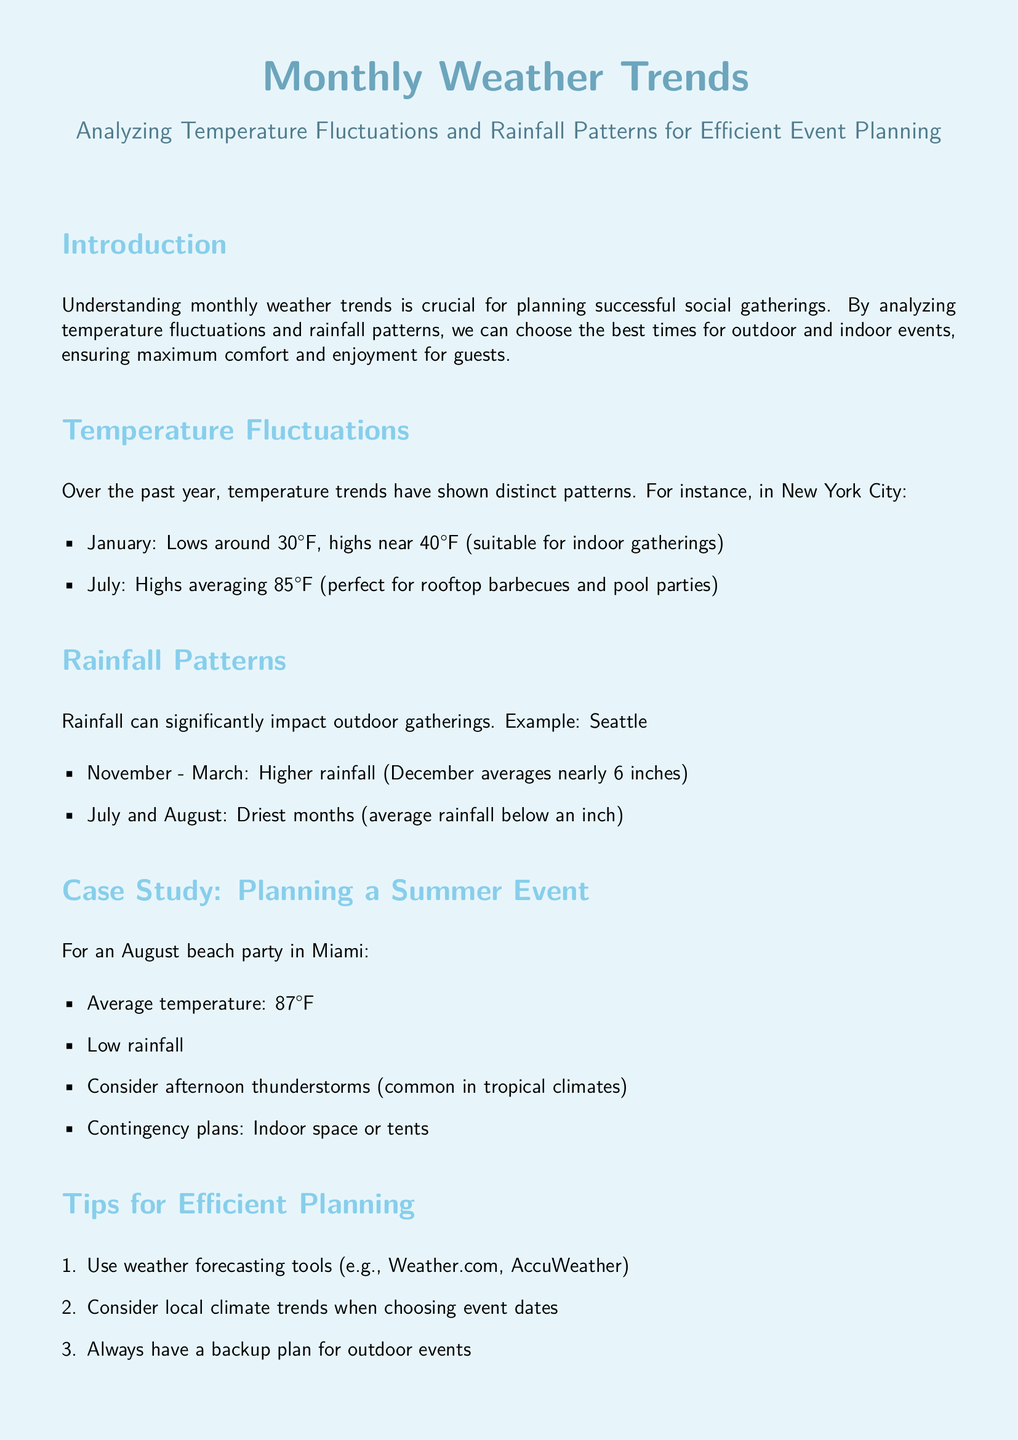What is the average temperature in August for Miami? The average temperature in August for Miami is stated as 87°F.
Answer: 87°F What months have the highest rainfall in Seattle? The document specifies that higher rainfall occurs from November to March, with December averages nearly 6 inches.
Answer: November - March What are the typical lows for January in New York City? The document indicates that January has lows around 30°F.
Answer: 30°F What is a recommended contingency plan for summer events? The tips suggest having a backup plan for outdoor events, such as an indoor space or tents.
Answer: Indoor space or tents Which months are considered the driest in Seattle? The text states that July and August are the driest months, with average rainfall below an inch.
Answer: July and August What tool is suggested for weather forecasting? The document mentions using weather forecasting tools like Weather.com and AccuWeather.
Answer: Weather.com, AccuWeather What is a key element to communicate to guests regarding outdoor events? The document notes that it's important to communicate potential weather issues to guests in advance.
Answer: Potential weather issues 